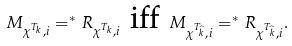<formula> <loc_0><loc_0><loc_500><loc_500>M _ { \chi ^ { T _ { k } } , i } = ^ { * } R _ { \chi ^ { T _ { k } } , i } \text { iff } M _ { \chi ^ { T _ { \widehat { k } } } , i } = ^ { * } R _ { \chi ^ { T _ { \widehat { k } } } , i } .</formula> 